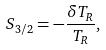<formula> <loc_0><loc_0><loc_500><loc_500>S _ { 3 / 2 } = - \frac { \delta T _ { R } } { T _ { R } } ,</formula> 